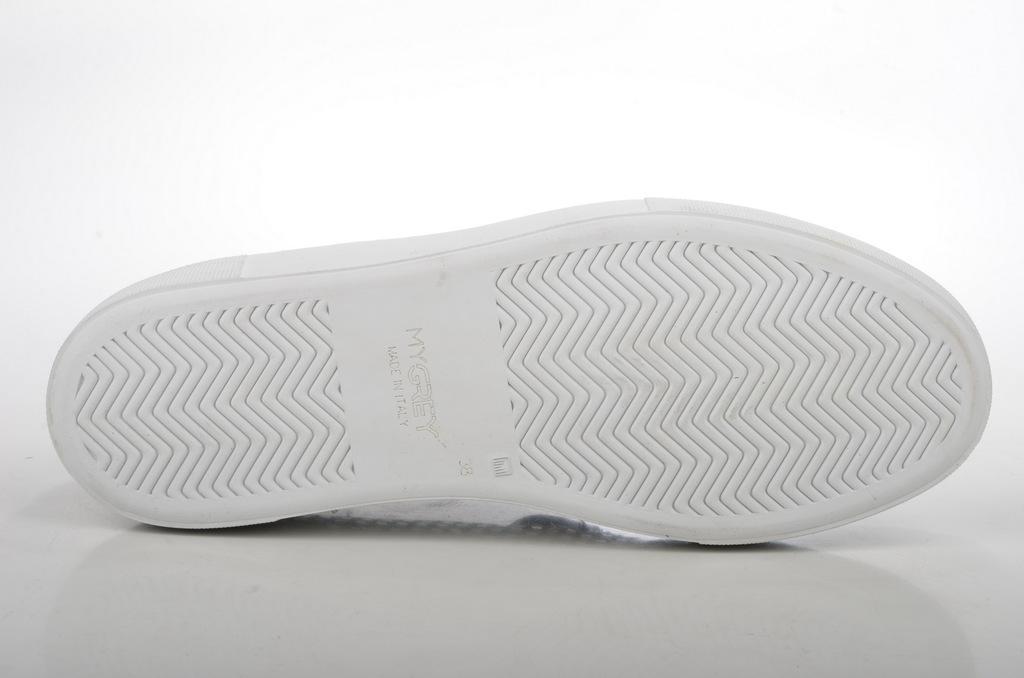Could you give a brief overview of what you see in this image? In this picture we can see a footwear and in the background we can see white color. 